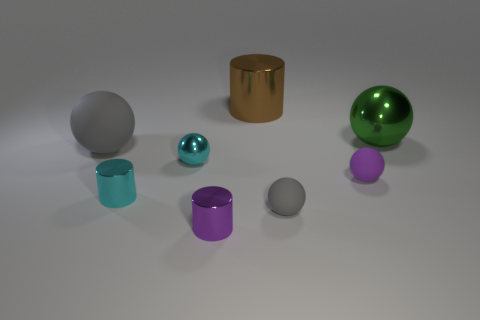What is the material of the green object?
Offer a very short reply. Metal. There is another ball that is the same color as the big rubber sphere; what is it made of?
Give a very brief answer. Rubber. What number of other things are there of the same material as the small purple sphere
Offer a very short reply. 2. There is a small shiny object that is in front of the cyan ball and behind the purple shiny thing; what shape is it?
Give a very brief answer. Cylinder. There is another large thing that is the same material as the brown thing; what color is it?
Your response must be concise. Green. Are there the same number of large brown shiny cylinders behind the cyan cylinder and brown objects?
Ensure brevity in your answer.  Yes. What is the shape of the purple thing that is the same size as the purple matte sphere?
Keep it short and to the point. Cylinder. What number of other objects are the same shape as the brown shiny object?
Keep it short and to the point. 2. There is a cyan metal cylinder; is it the same size as the metal ball that is to the left of the purple sphere?
Give a very brief answer. Yes. What number of things are cylinders that are behind the green metal sphere or tiny purple cylinders?
Your answer should be compact. 2. 